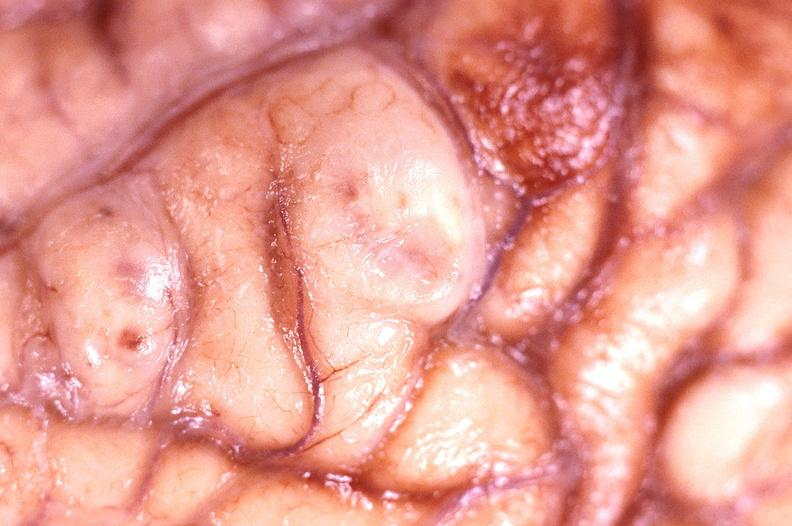does this image show brain abscess?
Answer the question using a single word or phrase. Yes 